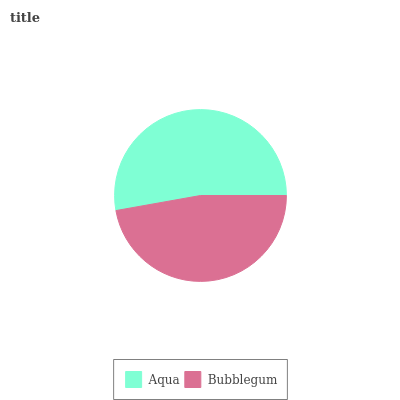Is Bubblegum the minimum?
Answer yes or no. Yes. Is Aqua the maximum?
Answer yes or no. Yes. Is Bubblegum the maximum?
Answer yes or no. No. Is Aqua greater than Bubblegum?
Answer yes or no. Yes. Is Bubblegum less than Aqua?
Answer yes or no. Yes. Is Bubblegum greater than Aqua?
Answer yes or no. No. Is Aqua less than Bubblegum?
Answer yes or no. No. Is Aqua the high median?
Answer yes or no. Yes. Is Bubblegum the low median?
Answer yes or no. Yes. Is Bubblegum the high median?
Answer yes or no. No. Is Aqua the low median?
Answer yes or no. No. 